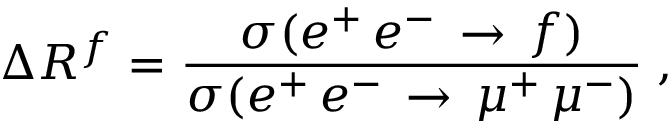Convert formula to latex. <formula><loc_0><loc_0><loc_500><loc_500>\Delta R ^ { f } = { \frac { \sigma ( e ^ { + } \, e ^ { - } \, \rightarrow \, f ) } { \sigma ( e ^ { + } \, e ^ { - } \, \rightarrow \, \mu ^ { + } \, \mu ^ { - } ) } } \, ,</formula> 